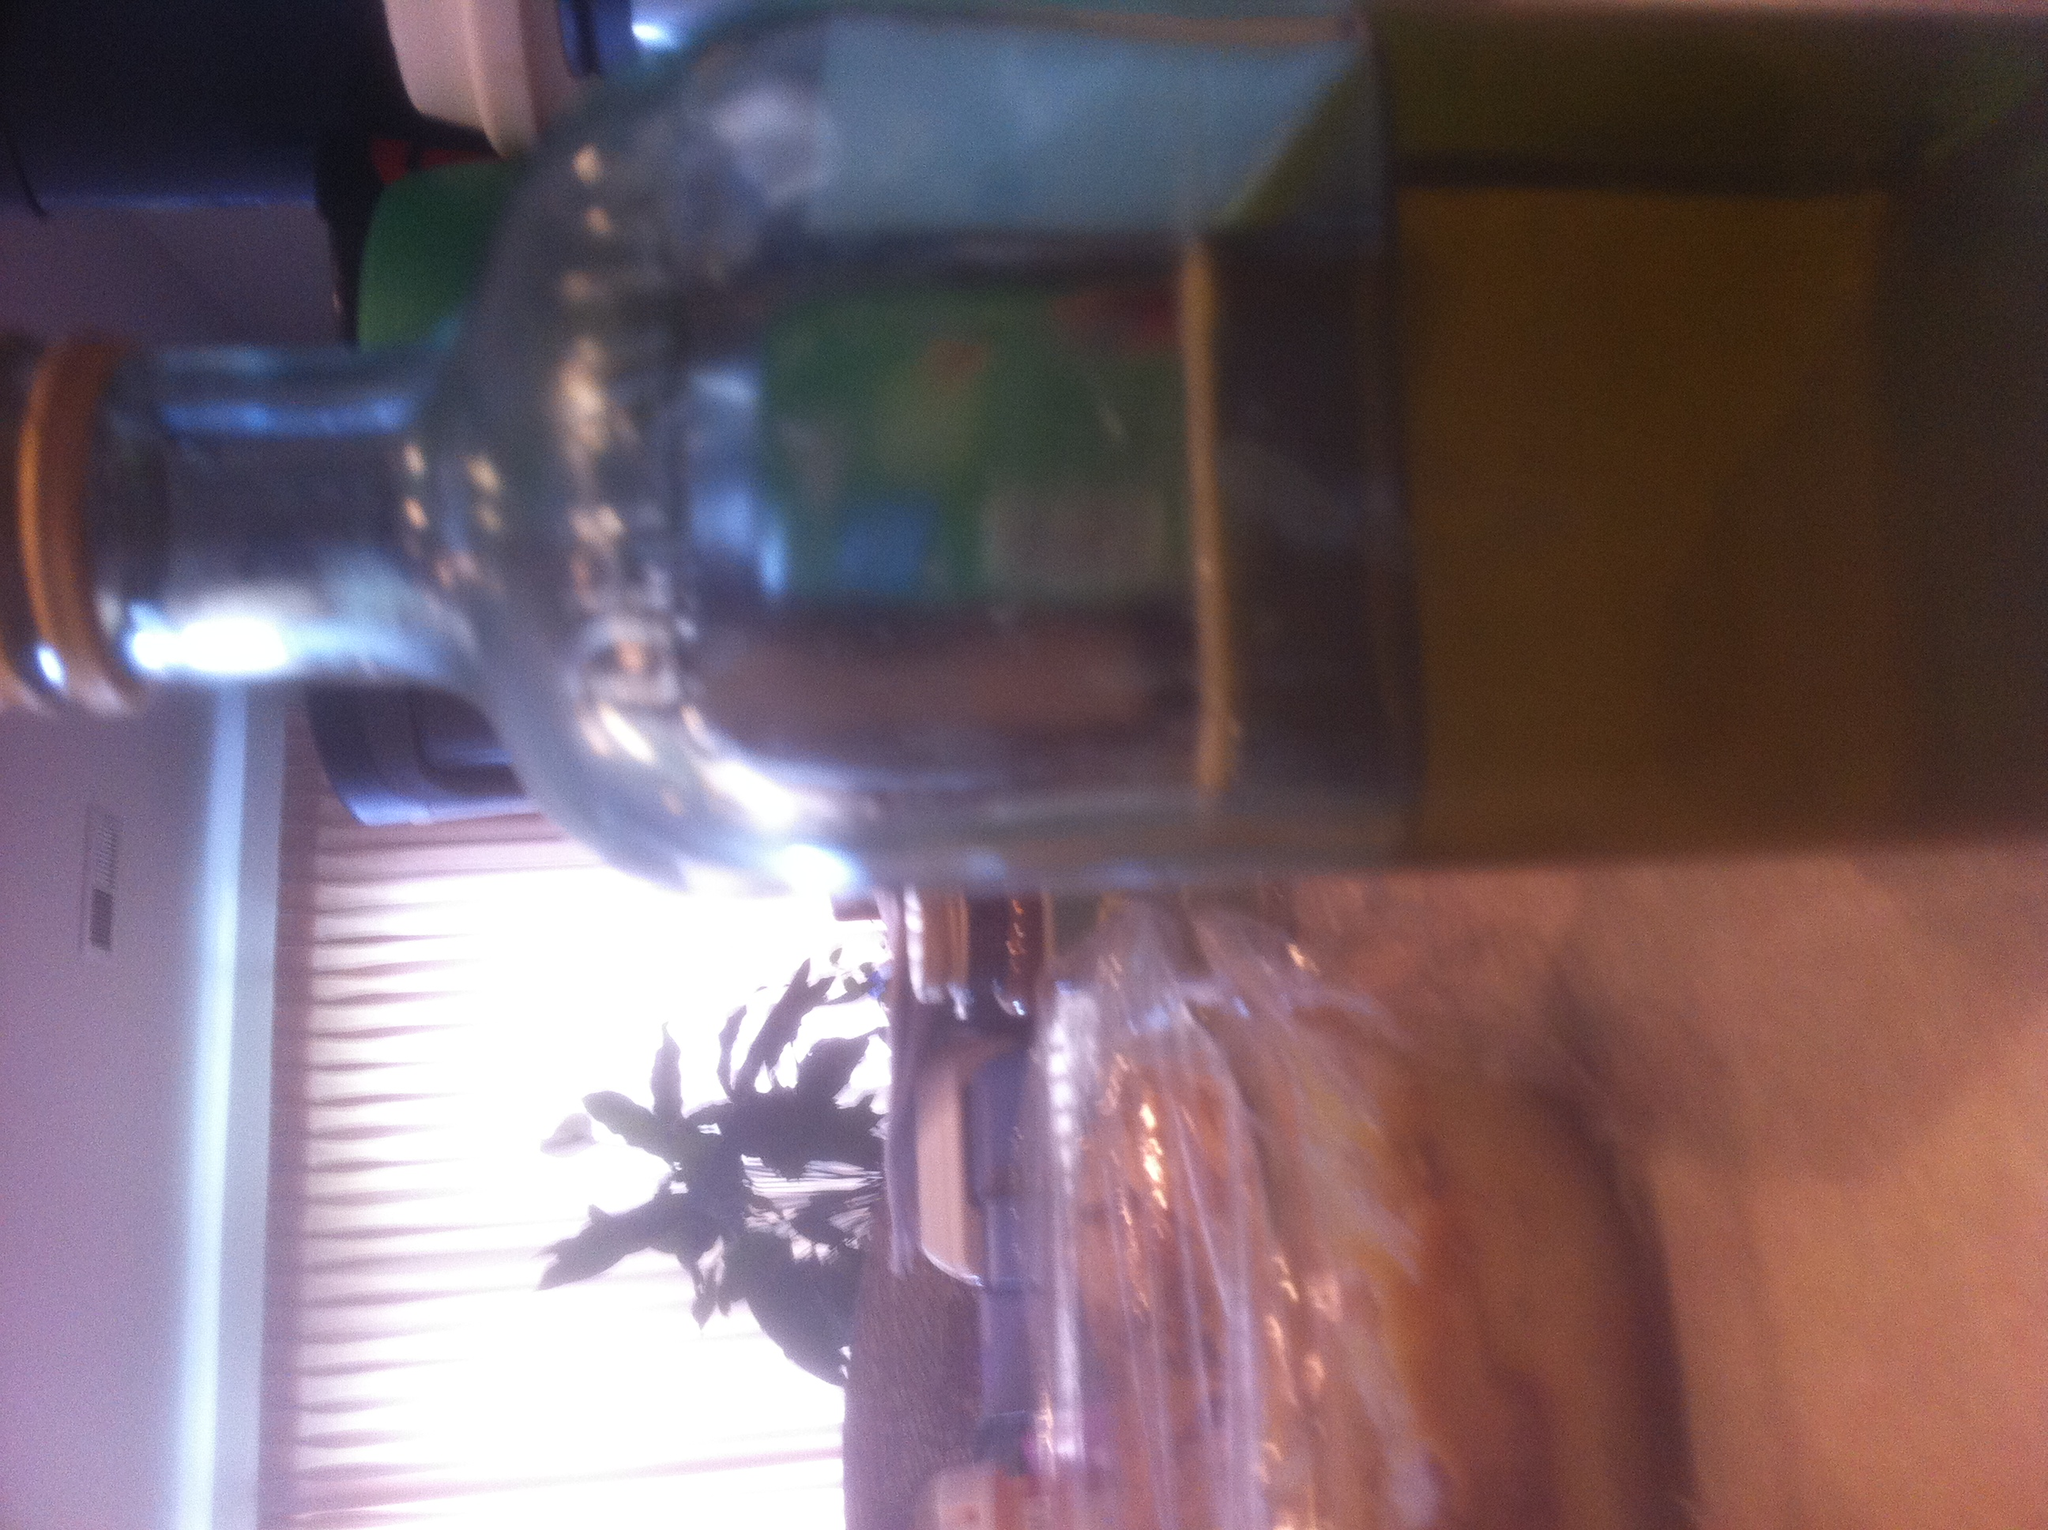What is this? This appears to be a glass bottle, possibly containing liquid. The contents could be oil, vinegar, a beverage, or some other substance commonly stored in glass bottles. It's placed on a kitchen or dining room table, suggesting it might be used during a meal or for cooking. 